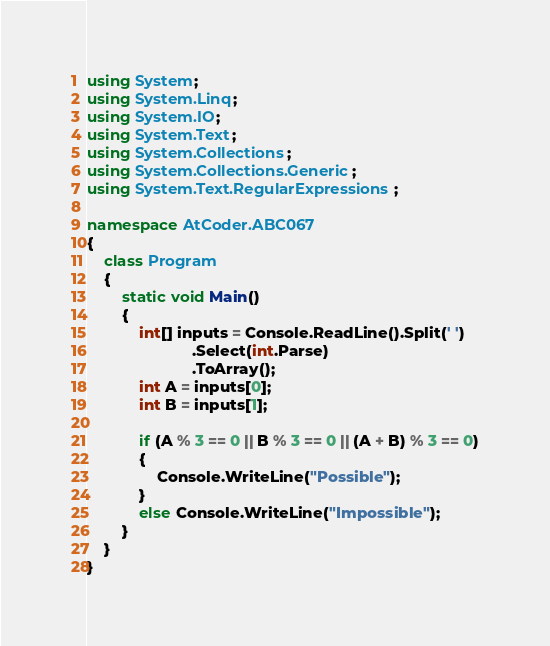Convert code to text. <code><loc_0><loc_0><loc_500><loc_500><_C#_>using System;
using System.Linq;
using System.IO;
using System.Text;
using System.Collections;
using System.Collections.Generic;
using System.Text.RegularExpressions;

namespace AtCoder.ABC067
{
    class Program
    {
        static void Main()
        {
            int[] inputs = Console.ReadLine().Split(' ')
                        .Select(int.Parse)
                        .ToArray();
            int A = inputs[0];
            int B = inputs[1];

            if (A % 3 == 0 || B % 3 == 0 || (A + B) % 3 == 0)
            {
                Console.WriteLine("Possible");
            }
            else Console.WriteLine("Impossible");
        }
    }
}</code> 